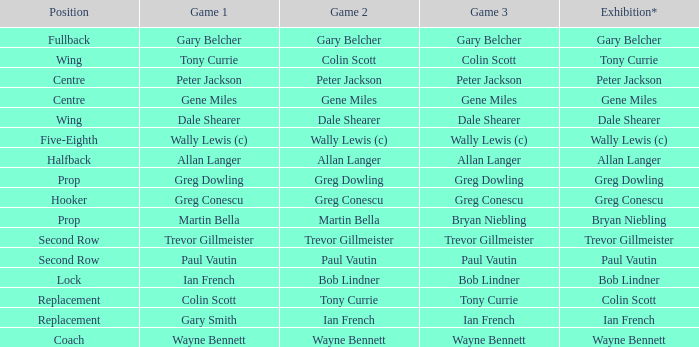What position has colin scott as game 1? Replacement. 